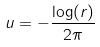<formula> <loc_0><loc_0><loc_500><loc_500>u = - \frac { \log ( r ) } { 2 \pi }</formula> 